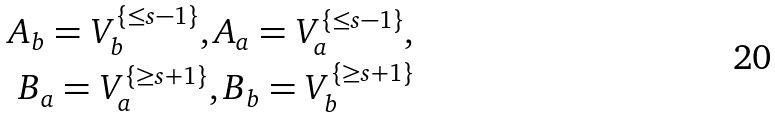<formula> <loc_0><loc_0><loc_500><loc_500>A _ { b } = V _ { b } ^ { \{ \leq s - 1 \} } , A _ { a } = V _ { a } ^ { \{ \leq s - 1 \} } , \\ B _ { a } = V _ { a } ^ { \{ \geq s + 1 \} } , B _ { b } = V _ { b } ^ { \{ \geq s + 1 \} }</formula> 